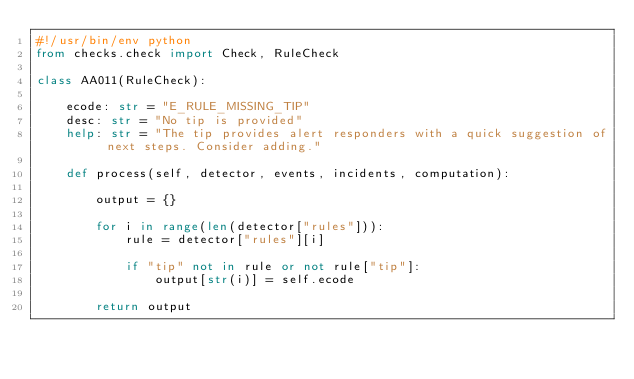Convert code to text. <code><loc_0><loc_0><loc_500><loc_500><_Python_>#!/usr/bin/env python
from checks.check import Check, RuleCheck

class AA011(RuleCheck):

    ecode: str = "E_RULE_MISSING_TIP"
    desc: str = "No tip is provided"
    help: str = "The tip provides alert responders with a quick suggestion of next steps. Consider adding."

    def process(self, detector, events, incidents, computation):

        output = {}

        for i in range(len(detector["rules"])):
            rule = detector["rules"][i]

            if "tip" not in rule or not rule["tip"]:
                output[str(i)] = self.ecode

        return output
</code> 